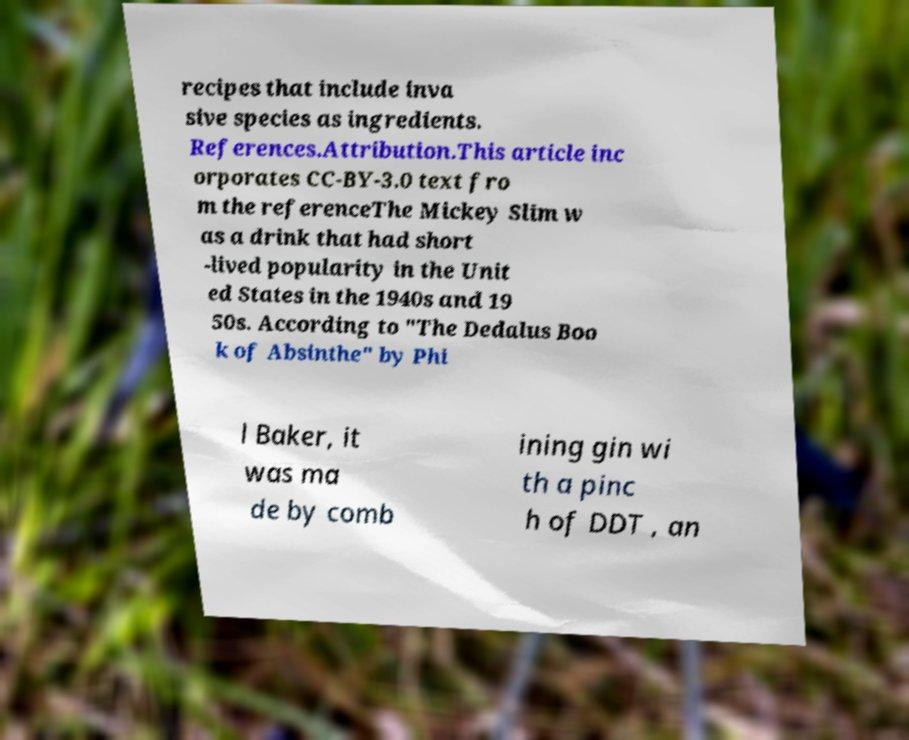Could you extract and type out the text from this image? recipes that include inva sive species as ingredients. References.Attribution.This article inc orporates CC-BY-3.0 text fro m the referenceThe Mickey Slim w as a drink that had short -lived popularity in the Unit ed States in the 1940s and 19 50s. According to "The Dedalus Boo k of Absinthe" by Phi l Baker, it was ma de by comb ining gin wi th a pinc h of DDT , an 